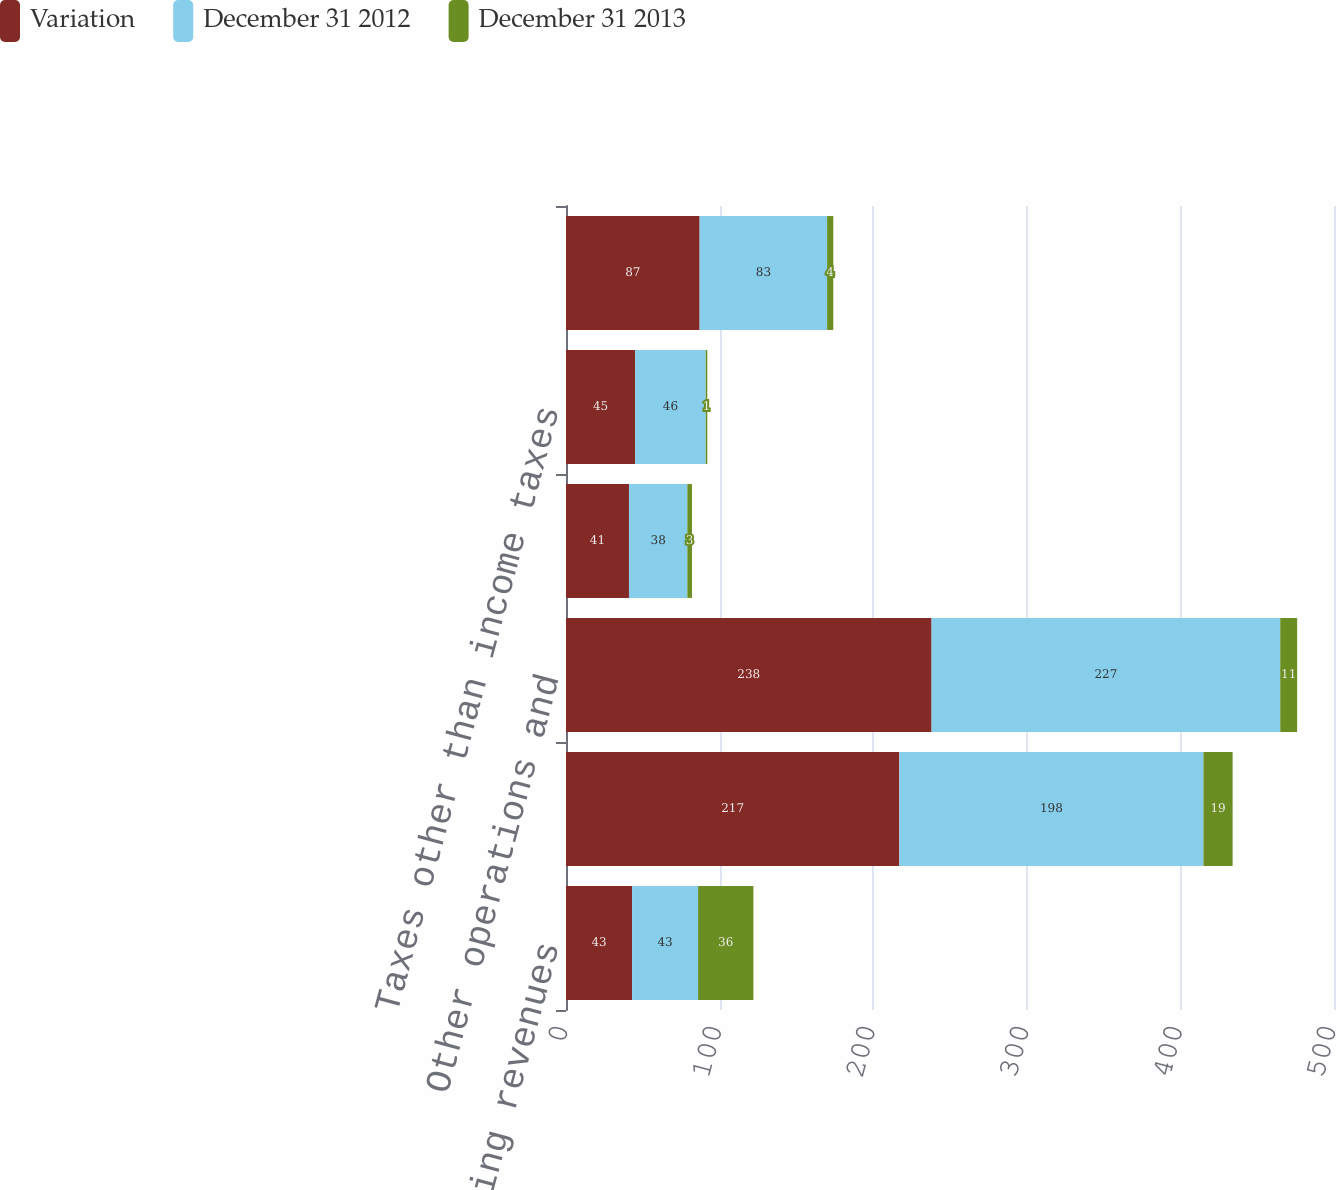Convert chart to OTSL. <chart><loc_0><loc_0><loc_500><loc_500><stacked_bar_chart><ecel><fcel>Operating revenues<fcel>Purchased power<fcel>Other operations and<fcel>Depreciation and amortization<fcel>Taxes other than income taxes<fcel>Electric operating income<nl><fcel>Variation<fcel>43<fcel>217<fcel>238<fcel>41<fcel>45<fcel>87<nl><fcel>December 31 2012<fcel>43<fcel>198<fcel>227<fcel>38<fcel>46<fcel>83<nl><fcel>December 31 2013<fcel>36<fcel>19<fcel>11<fcel>3<fcel>1<fcel>4<nl></chart> 